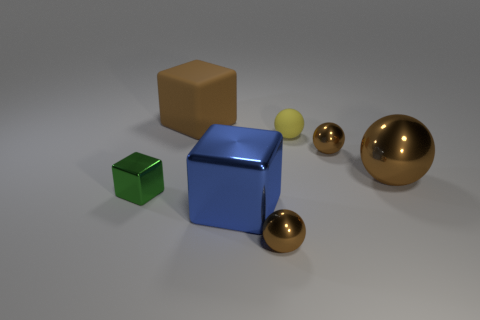There is a object left of the large brown rubber object; how many brown blocks are in front of it?
Your answer should be very brief. 0. Do the big brown shiny object and the big blue thing have the same shape?
Offer a terse response. No. Is there any other thing of the same color as the big metallic cube?
Offer a terse response. No. Is the shape of the small yellow object the same as the big metallic thing left of the tiny matte object?
Offer a terse response. No. What color is the small ball on the right side of the small yellow rubber ball that is behind the block in front of the green block?
Provide a short and direct response. Brown. Is there anything else that is the same material as the tiny green thing?
Offer a terse response. Yes. Is the shape of the small object right of the yellow sphere the same as  the small yellow object?
Offer a very short reply. Yes. What material is the large blue object?
Offer a terse response. Metal. What is the shape of the tiny metallic object that is in front of the large shiny object that is on the left side of the tiny brown object that is in front of the green metallic block?
Offer a terse response. Sphere. How many other objects are the same shape as the green thing?
Provide a succinct answer. 2. 